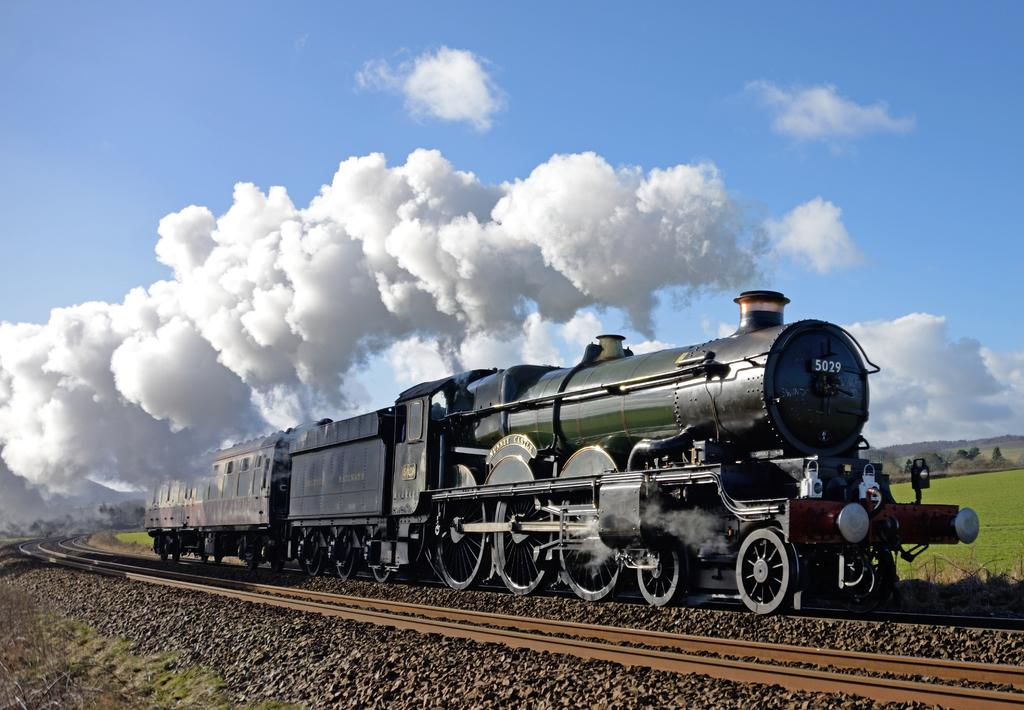What is the main subject of the image? The main subject of the image is a train. What is the train doing in the image? The train is moving on a track. What can be seen in the background as the train moves? The train is leaving smoke in the background. What type of natural environment is visible in the background? There is grassland and trees visible in the background. What else can be seen in the sky in the background? The sky is visible in the background. What time is displayed on the clock in the image? There is no clock present in the image. What emotion can be seen on the faces of the people in the image? There are no people visible in the image; it only features a train and its surroundings. 